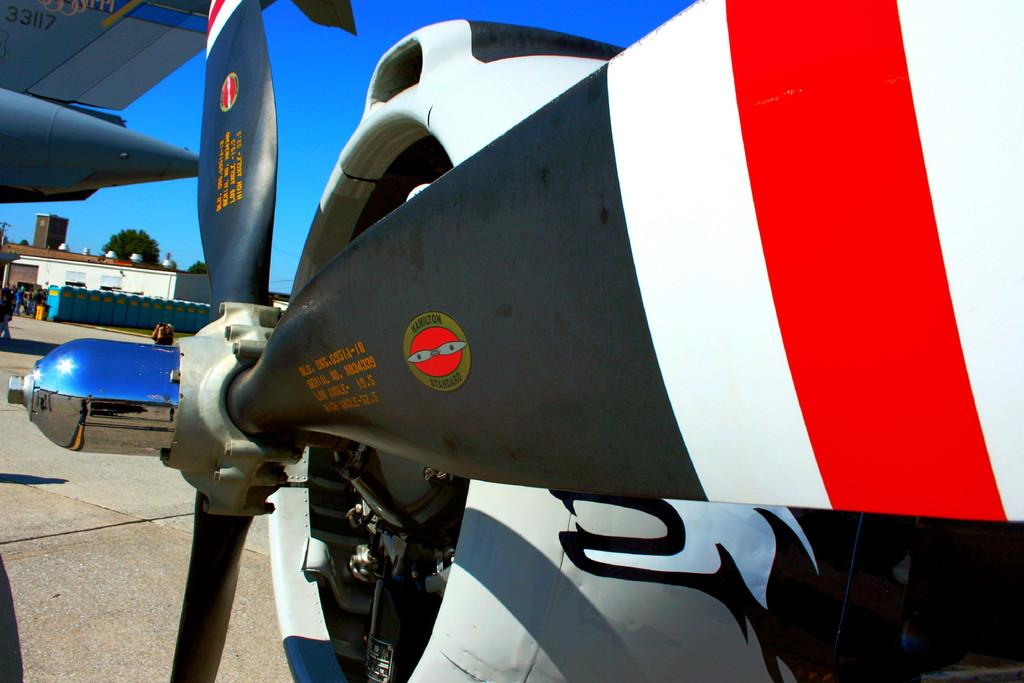<image>
Offer a succinct explanation of the picture presented. An airplane with the words Hamilton standard written on the propeller 